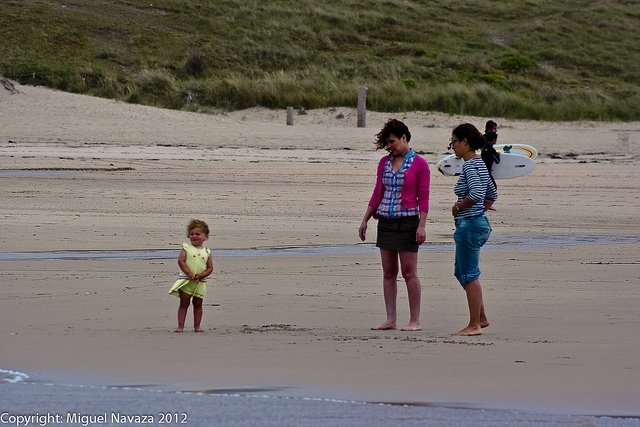Describe the objects in this image and their specific colors. I can see people in black, purple, darkgray, and gray tones, people in black, navy, maroon, and darkgray tones, people in black, darkgray, and maroon tones, surfboard in black and gray tones, and people in black, gray, darkgray, and navy tones in this image. 